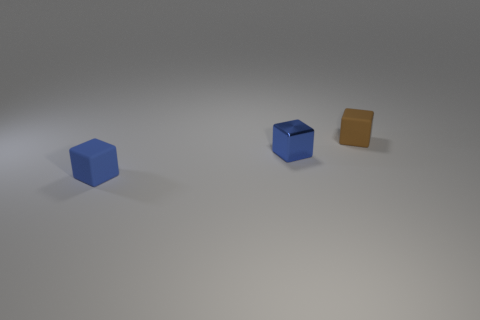Add 2 big red shiny cylinders. How many objects exist? 5 Add 2 small blue rubber cubes. How many small blue rubber cubes exist? 3 Subtract 0 purple cylinders. How many objects are left? 3 Subtract all blue matte spheres. Subtract all tiny metallic cubes. How many objects are left? 2 Add 3 tiny matte cubes. How many tiny matte cubes are left? 5 